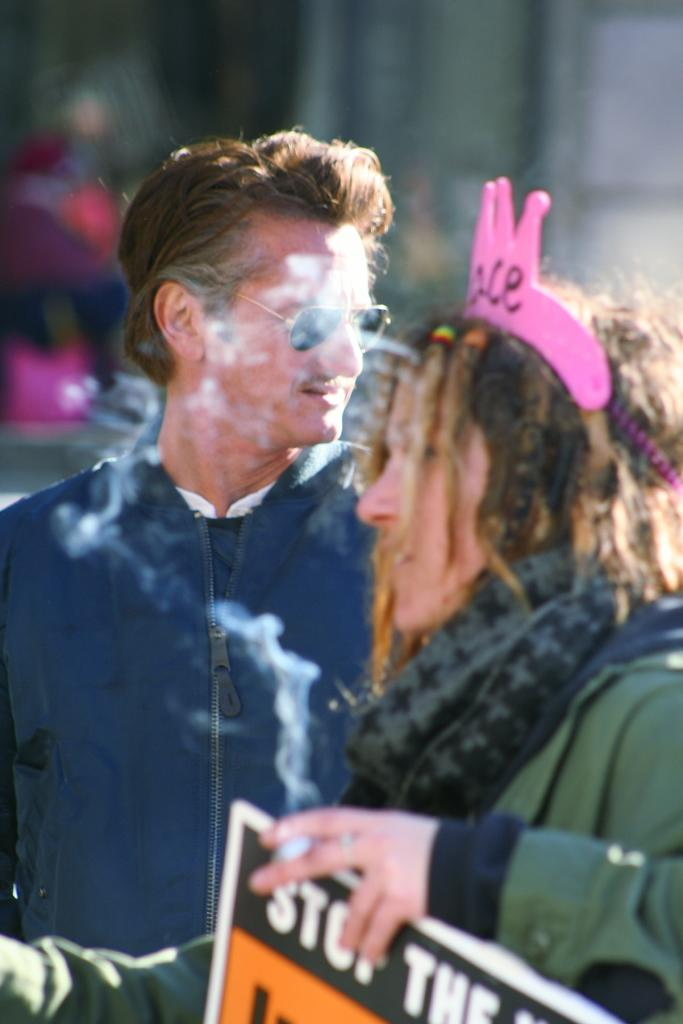How many people are present in the image? There are two people standing in the image. What is the woman holding in the image? The woman is holding a board and a cigarette. Can you describe the background of the image? The background of the image is blurred. How many snails can be seen crawling on the board in the image? There are no snails visible in the image. What type of mint is being used to flavor the cigarette in the image? There is no mention of mint or any specific flavor for the cigarette in the image. 